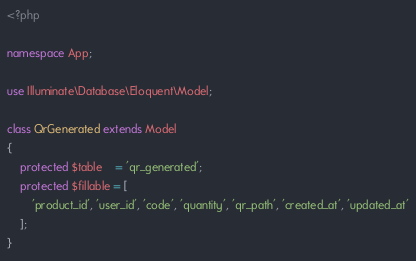Convert code to text. <code><loc_0><loc_0><loc_500><loc_500><_PHP_><?php

namespace App;

use Illuminate\Database\Eloquent\Model;

class QrGenerated extends Model
{
    protected $table    = 'qr_generated';
    protected $fillable = [
        'product_id', 'user_id', 'code', 'quantity', 'qr_path', 'created_at', 'updated_at'
    ];
}
</code> 